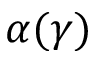<formula> <loc_0><loc_0><loc_500><loc_500>\alpha ( \gamma )</formula> 